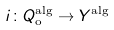Convert formula to latex. <formula><loc_0><loc_0><loc_500><loc_500>i \colon Q _ { \text {o} } ^ { \text {alg} } \rightarrow Y ^ { \text {alg} }</formula> 